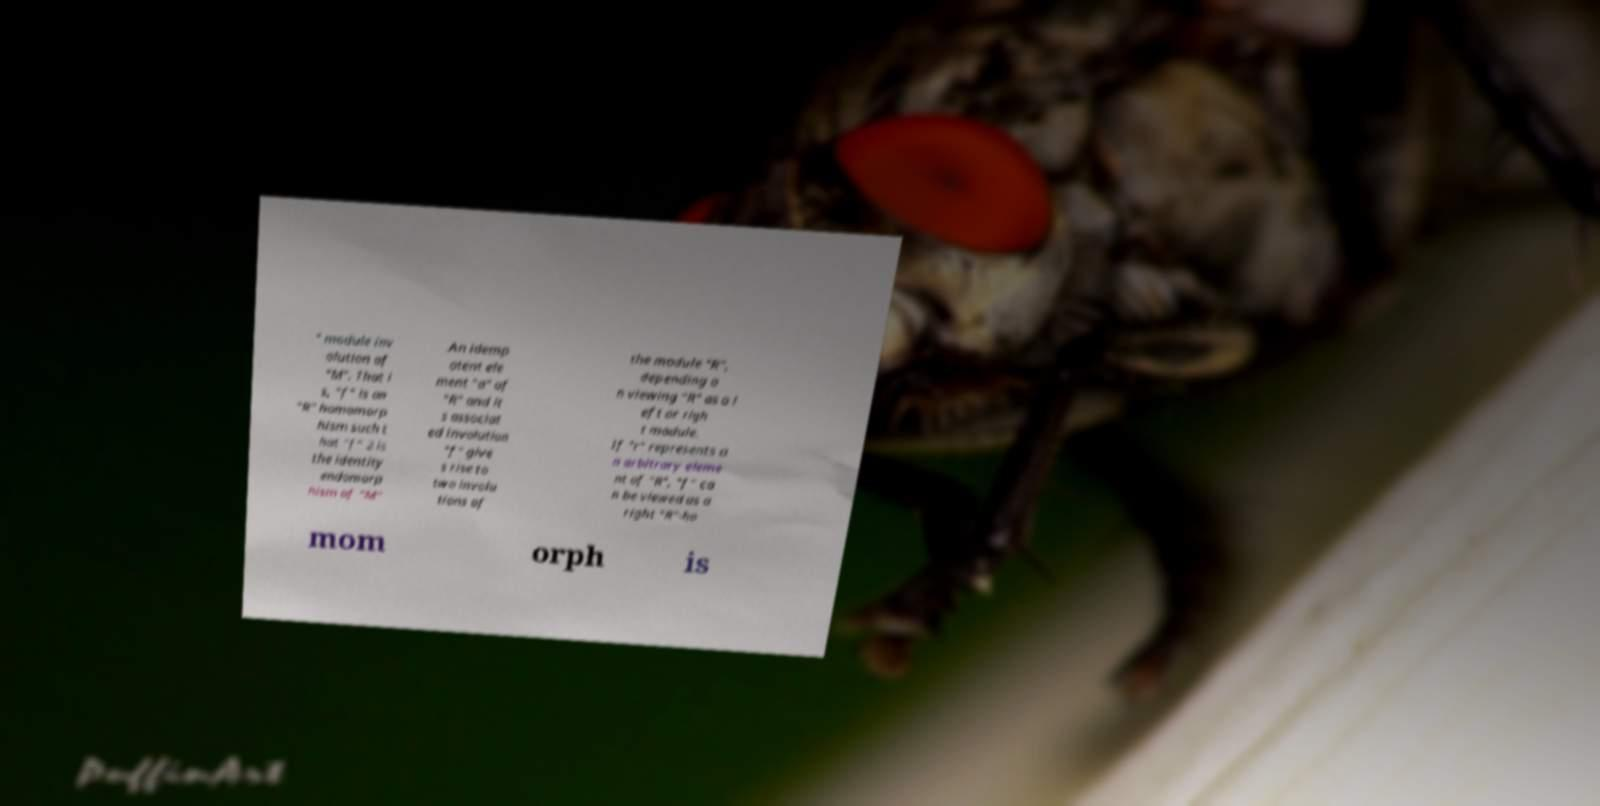Can you read and provide the text displayed in the image?This photo seems to have some interesting text. Can you extract and type it out for me? " module inv olution of "M". That i s, "f" is an "R" homomorp hism such t hat "f" 2 is the identity endomorp hism of "M" .An idemp otent ele ment "a" of "R" and it s associat ed involution "f" give s rise to two involu tions of the module "R", depending o n viewing "R" as a l eft or righ t module. If "r" represents a n arbitrary eleme nt of "R", "f" ca n be viewed as a right "R"-ho mom orph is 